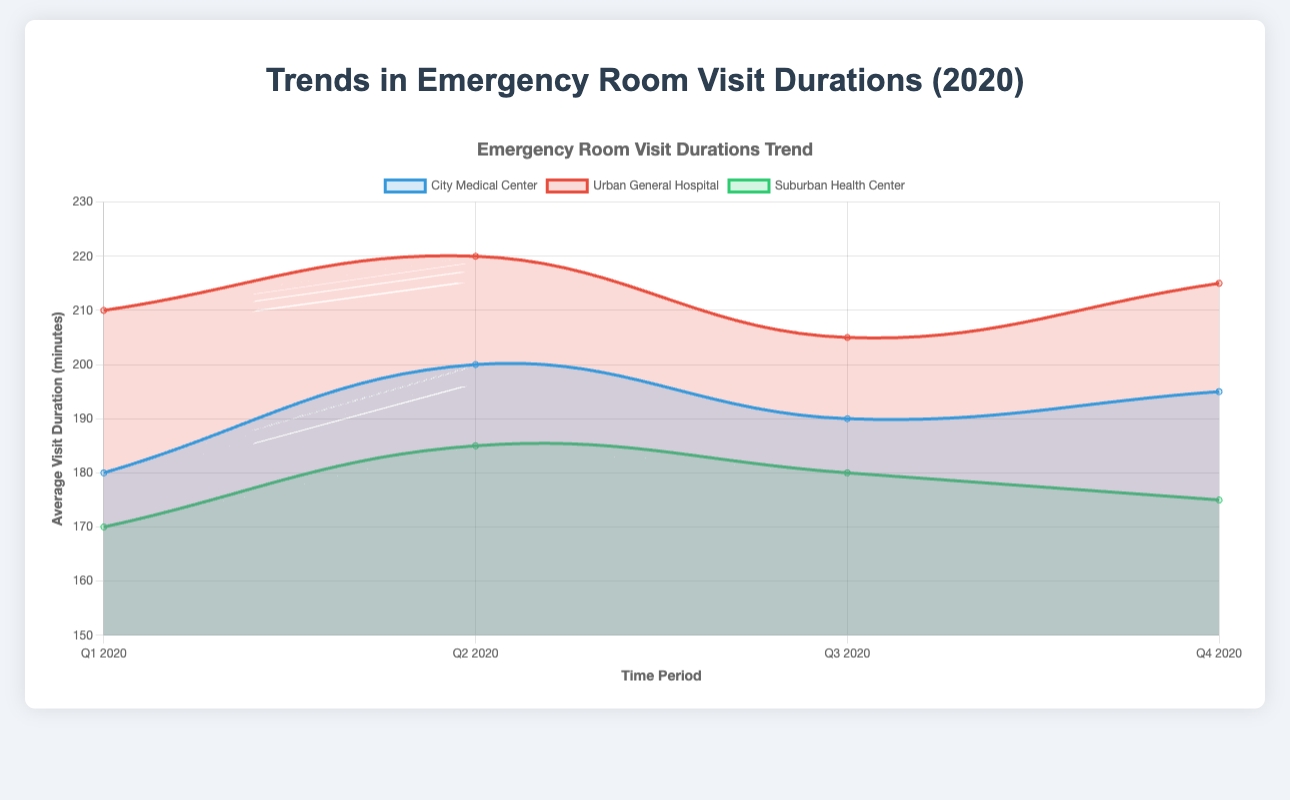What is the average visit duration for City Medical Center in Q3 2020? The chart shows that the average visit duration for City Medical Center in Q3 2020 is plotted as a point along the trend line for that hospital. Locate this point on the chart.
Answer: 190 Which hospital had the longest average emergency room visit duration in Q2 2020? To find this, locate the Q2 2020 time period on the x-axis and then compare the height of the data points for the three hospitals. The highest data point represents the longest average visit duration.
Answer: Urban General Hospital How did the average visit duration for Suburban Health Center change from Q1 2020 to Q4 2020? Follow the trend line for Suburban Health Center from Q1 to Q4. Compare the value of the points at both ends.
Answer: Decreased from 170 minutes to 175 minutes What is the difference in average visit duration between City Medical Center and Urban General Hospital in Q4 2020? Locate the average visit durations for both hospitals in Q4 2020 and calculate the difference by subtracting the lower value from the higher value.
Answer: 20 minutes During which quarter did City Medical Center have the highest number of visits? Refer to the tooltip information for City Medical Center data points, comparing the number of visits for each quarter.
Answer: Q3 2020 Which hospital showed a decreasing trend in average visit durations from Q1 2020 to Q4 2020? Examine the trend lines of all hospitals. Identify the one whose line slopes downward consistently from Q1 to Q4.
Answer: Suburban Health Center Compare the average visit durations of all hospitals for Q1 2020. Which hospital had the shortest average duration? For Q1 2020, compare the heights of the data points for all hospitals. The shortest duration corresponds to the lowest point on the chart.
Answer: Suburban Health Center What is the sum of average visit durations for Urban General Hospital in all quarters? Add up the average visit durations for Urban General Hospital across all quarters: 210 + 220 + 205 + 215.
Answer: 850 Are there any hospitals with an increasing trend in average visit durations over the year? Check the trend lines of each hospital to determine if any of them have a generally upward slope from Q1 to Q4.
Answer: Urban General Hospital Is the average visit duration for City Medical Center higher or lower than Suburban Health Center in Q2 2020? Compare the heights of the data points for these hospitals in Q2 2020.
Answer: Higher 